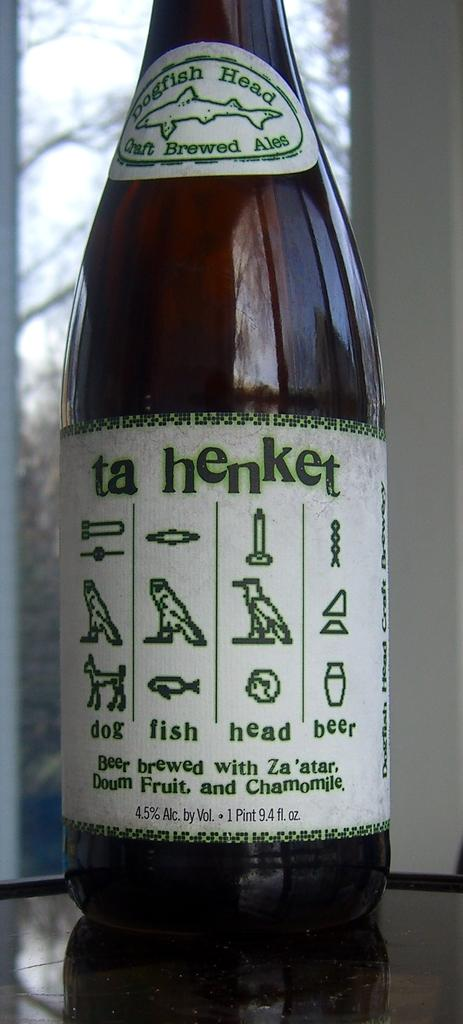<image>
Provide a brief description of the given image. A bottle of Ta Hebket feature Egyptian Heiroglyphs. 